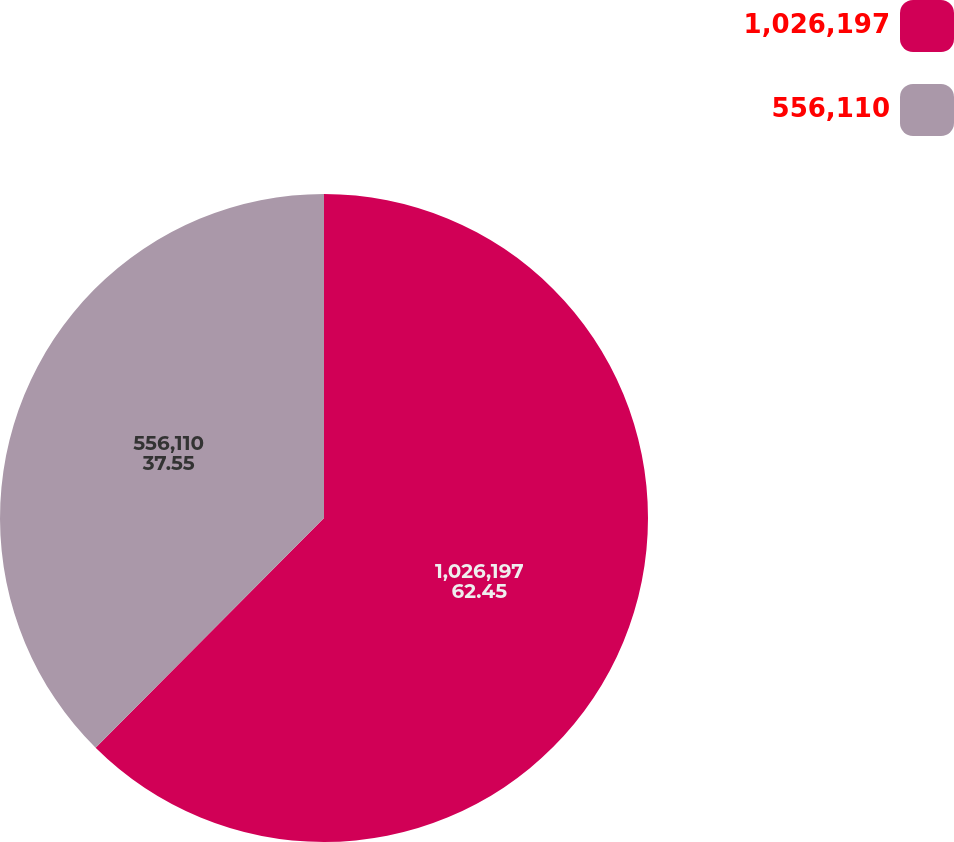Convert chart to OTSL. <chart><loc_0><loc_0><loc_500><loc_500><pie_chart><fcel>1,026,197<fcel>556,110<nl><fcel>62.45%<fcel>37.55%<nl></chart> 